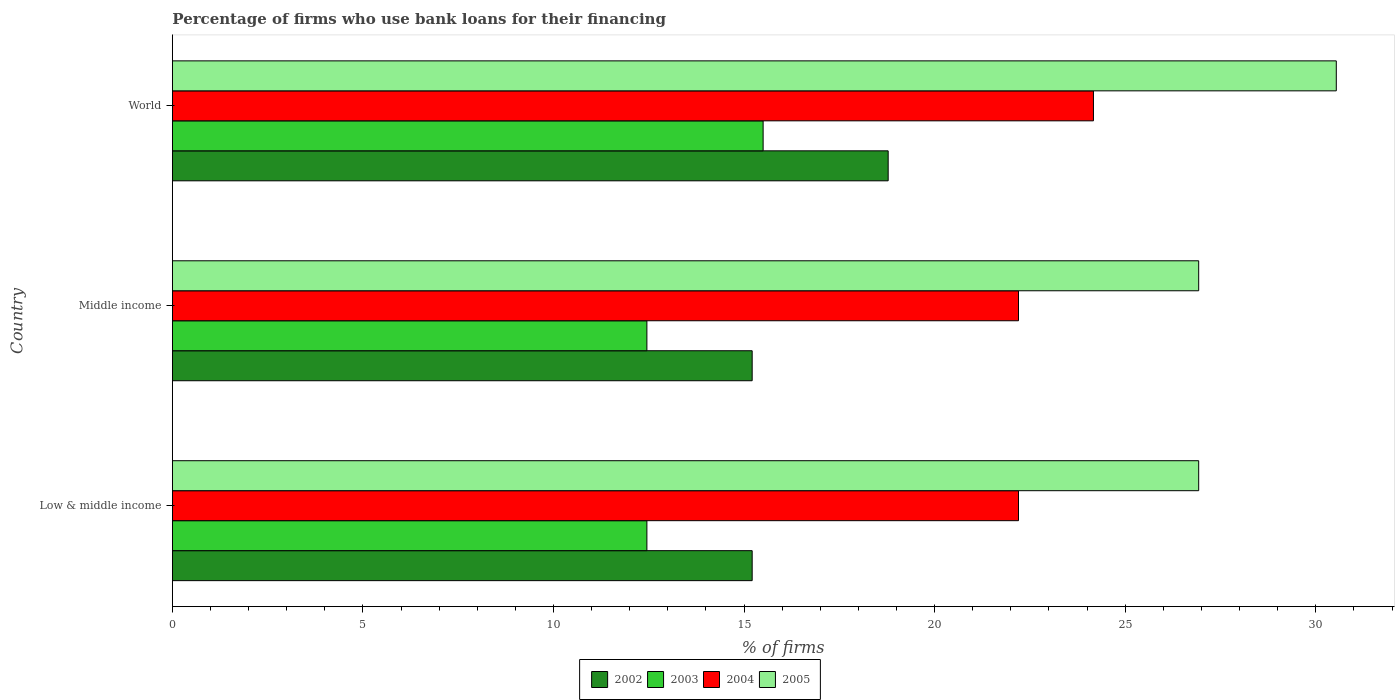How many groups of bars are there?
Ensure brevity in your answer.  3. Are the number of bars per tick equal to the number of legend labels?
Offer a very short reply. Yes. Are the number of bars on each tick of the Y-axis equal?
Your answer should be very brief. Yes. How many bars are there on the 3rd tick from the bottom?
Your answer should be compact. 4. What is the percentage of firms who use bank loans for their financing in 2003 in Low & middle income?
Provide a succinct answer. 12.45. Across all countries, what is the maximum percentage of firms who use bank loans for their financing in 2002?
Your response must be concise. 18.78. Across all countries, what is the minimum percentage of firms who use bank loans for their financing in 2003?
Provide a succinct answer. 12.45. What is the total percentage of firms who use bank loans for their financing in 2003 in the graph?
Keep it short and to the point. 40.4. What is the difference between the percentage of firms who use bank loans for their financing in 2004 in Middle income and that in World?
Offer a terse response. -1.97. What is the difference between the percentage of firms who use bank loans for their financing in 2005 in Middle income and the percentage of firms who use bank loans for their financing in 2002 in World?
Offer a terse response. 8.15. What is the average percentage of firms who use bank loans for their financing in 2005 per country?
Your answer should be very brief. 28.13. What is the difference between the percentage of firms who use bank loans for their financing in 2004 and percentage of firms who use bank loans for their financing in 2005 in Middle income?
Offer a very short reply. -4.73. In how many countries, is the percentage of firms who use bank loans for their financing in 2002 greater than 25 %?
Provide a succinct answer. 0. What is the ratio of the percentage of firms who use bank loans for their financing in 2004 in Low & middle income to that in World?
Ensure brevity in your answer.  0.92. What is the difference between the highest and the second highest percentage of firms who use bank loans for their financing in 2004?
Provide a succinct answer. 1.97. What is the difference between the highest and the lowest percentage of firms who use bank loans for their financing in 2002?
Provide a succinct answer. 3.57. In how many countries, is the percentage of firms who use bank loans for their financing in 2005 greater than the average percentage of firms who use bank loans for their financing in 2005 taken over all countries?
Provide a short and direct response. 1. What does the 2nd bar from the bottom in Low & middle income represents?
Offer a terse response. 2003. Are all the bars in the graph horizontal?
Provide a succinct answer. Yes. How many countries are there in the graph?
Your response must be concise. 3. What is the difference between two consecutive major ticks on the X-axis?
Offer a very short reply. 5. Does the graph contain grids?
Keep it short and to the point. No. How many legend labels are there?
Keep it short and to the point. 4. What is the title of the graph?
Ensure brevity in your answer.  Percentage of firms who use bank loans for their financing. Does "1970" appear as one of the legend labels in the graph?
Ensure brevity in your answer.  No. What is the label or title of the X-axis?
Ensure brevity in your answer.  % of firms. What is the label or title of the Y-axis?
Your answer should be very brief. Country. What is the % of firms of 2002 in Low & middle income?
Offer a terse response. 15.21. What is the % of firms in 2003 in Low & middle income?
Offer a terse response. 12.45. What is the % of firms of 2004 in Low & middle income?
Provide a succinct answer. 22.2. What is the % of firms of 2005 in Low & middle income?
Ensure brevity in your answer.  26.93. What is the % of firms of 2002 in Middle income?
Offer a terse response. 15.21. What is the % of firms of 2003 in Middle income?
Your answer should be very brief. 12.45. What is the % of firms in 2004 in Middle income?
Provide a short and direct response. 22.2. What is the % of firms of 2005 in Middle income?
Make the answer very short. 26.93. What is the % of firms in 2002 in World?
Your response must be concise. 18.78. What is the % of firms of 2003 in World?
Your answer should be very brief. 15.5. What is the % of firms of 2004 in World?
Offer a very short reply. 24.17. What is the % of firms of 2005 in World?
Offer a terse response. 30.54. Across all countries, what is the maximum % of firms of 2002?
Keep it short and to the point. 18.78. Across all countries, what is the maximum % of firms in 2003?
Provide a short and direct response. 15.5. Across all countries, what is the maximum % of firms of 2004?
Provide a succinct answer. 24.17. Across all countries, what is the maximum % of firms of 2005?
Your response must be concise. 30.54. Across all countries, what is the minimum % of firms of 2002?
Your answer should be compact. 15.21. Across all countries, what is the minimum % of firms in 2003?
Keep it short and to the point. 12.45. Across all countries, what is the minimum % of firms in 2004?
Offer a very short reply. 22.2. Across all countries, what is the minimum % of firms in 2005?
Provide a succinct answer. 26.93. What is the total % of firms in 2002 in the graph?
Offer a terse response. 49.21. What is the total % of firms in 2003 in the graph?
Make the answer very short. 40.4. What is the total % of firms of 2004 in the graph?
Make the answer very short. 68.57. What is the total % of firms of 2005 in the graph?
Your answer should be very brief. 84.39. What is the difference between the % of firms of 2002 in Low & middle income and that in Middle income?
Make the answer very short. 0. What is the difference between the % of firms of 2002 in Low & middle income and that in World?
Offer a terse response. -3.57. What is the difference between the % of firms of 2003 in Low & middle income and that in World?
Your response must be concise. -3.05. What is the difference between the % of firms in 2004 in Low & middle income and that in World?
Your answer should be compact. -1.97. What is the difference between the % of firms in 2005 in Low & middle income and that in World?
Give a very brief answer. -3.61. What is the difference between the % of firms of 2002 in Middle income and that in World?
Offer a very short reply. -3.57. What is the difference between the % of firms in 2003 in Middle income and that in World?
Your answer should be very brief. -3.05. What is the difference between the % of firms in 2004 in Middle income and that in World?
Ensure brevity in your answer.  -1.97. What is the difference between the % of firms in 2005 in Middle income and that in World?
Provide a short and direct response. -3.61. What is the difference between the % of firms in 2002 in Low & middle income and the % of firms in 2003 in Middle income?
Your response must be concise. 2.76. What is the difference between the % of firms of 2002 in Low & middle income and the % of firms of 2004 in Middle income?
Provide a short and direct response. -6.99. What is the difference between the % of firms in 2002 in Low & middle income and the % of firms in 2005 in Middle income?
Offer a very short reply. -11.72. What is the difference between the % of firms in 2003 in Low & middle income and the % of firms in 2004 in Middle income?
Give a very brief answer. -9.75. What is the difference between the % of firms in 2003 in Low & middle income and the % of firms in 2005 in Middle income?
Provide a short and direct response. -14.48. What is the difference between the % of firms of 2004 in Low & middle income and the % of firms of 2005 in Middle income?
Keep it short and to the point. -4.73. What is the difference between the % of firms of 2002 in Low & middle income and the % of firms of 2003 in World?
Provide a succinct answer. -0.29. What is the difference between the % of firms of 2002 in Low & middle income and the % of firms of 2004 in World?
Ensure brevity in your answer.  -8.95. What is the difference between the % of firms of 2002 in Low & middle income and the % of firms of 2005 in World?
Keep it short and to the point. -15.33. What is the difference between the % of firms of 2003 in Low & middle income and the % of firms of 2004 in World?
Ensure brevity in your answer.  -11.72. What is the difference between the % of firms of 2003 in Low & middle income and the % of firms of 2005 in World?
Provide a succinct answer. -18.09. What is the difference between the % of firms of 2004 in Low & middle income and the % of firms of 2005 in World?
Your answer should be very brief. -8.34. What is the difference between the % of firms of 2002 in Middle income and the % of firms of 2003 in World?
Provide a succinct answer. -0.29. What is the difference between the % of firms of 2002 in Middle income and the % of firms of 2004 in World?
Your response must be concise. -8.95. What is the difference between the % of firms in 2002 in Middle income and the % of firms in 2005 in World?
Make the answer very short. -15.33. What is the difference between the % of firms of 2003 in Middle income and the % of firms of 2004 in World?
Offer a very short reply. -11.72. What is the difference between the % of firms in 2003 in Middle income and the % of firms in 2005 in World?
Provide a succinct answer. -18.09. What is the difference between the % of firms in 2004 in Middle income and the % of firms in 2005 in World?
Your answer should be very brief. -8.34. What is the average % of firms in 2002 per country?
Make the answer very short. 16.4. What is the average % of firms in 2003 per country?
Provide a short and direct response. 13.47. What is the average % of firms in 2004 per country?
Provide a succinct answer. 22.86. What is the average % of firms in 2005 per country?
Your response must be concise. 28.13. What is the difference between the % of firms in 2002 and % of firms in 2003 in Low & middle income?
Provide a succinct answer. 2.76. What is the difference between the % of firms in 2002 and % of firms in 2004 in Low & middle income?
Your response must be concise. -6.99. What is the difference between the % of firms of 2002 and % of firms of 2005 in Low & middle income?
Your answer should be very brief. -11.72. What is the difference between the % of firms of 2003 and % of firms of 2004 in Low & middle income?
Provide a short and direct response. -9.75. What is the difference between the % of firms in 2003 and % of firms in 2005 in Low & middle income?
Give a very brief answer. -14.48. What is the difference between the % of firms in 2004 and % of firms in 2005 in Low & middle income?
Offer a terse response. -4.73. What is the difference between the % of firms of 2002 and % of firms of 2003 in Middle income?
Ensure brevity in your answer.  2.76. What is the difference between the % of firms of 2002 and % of firms of 2004 in Middle income?
Your answer should be very brief. -6.99. What is the difference between the % of firms in 2002 and % of firms in 2005 in Middle income?
Offer a very short reply. -11.72. What is the difference between the % of firms of 2003 and % of firms of 2004 in Middle income?
Your answer should be very brief. -9.75. What is the difference between the % of firms in 2003 and % of firms in 2005 in Middle income?
Your answer should be very brief. -14.48. What is the difference between the % of firms of 2004 and % of firms of 2005 in Middle income?
Provide a short and direct response. -4.73. What is the difference between the % of firms in 2002 and % of firms in 2003 in World?
Keep it short and to the point. 3.28. What is the difference between the % of firms in 2002 and % of firms in 2004 in World?
Your answer should be compact. -5.39. What is the difference between the % of firms of 2002 and % of firms of 2005 in World?
Keep it short and to the point. -11.76. What is the difference between the % of firms of 2003 and % of firms of 2004 in World?
Make the answer very short. -8.67. What is the difference between the % of firms of 2003 and % of firms of 2005 in World?
Ensure brevity in your answer.  -15.04. What is the difference between the % of firms of 2004 and % of firms of 2005 in World?
Ensure brevity in your answer.  -6.37. What is the ratio of the % of firms in 2002 in Low & middle income to that in Middle income?
Offer a very short reply. 1. What is the ratio of the % of firms of 2005 in Low & middle income to that in Middle income?
Provide a succinct answer. 1. What is the ratio of the % of firms of 2002 in Low & middle income to that in World?
Keep it short and to the point. 0.81. What is the ratio of the % of firms in 2003 in Low & middle income to that in World?
Your response must be concise. 0.8. What is the ratio of the % of firms in 2004 in Low & middle income to that in World?
Ensure brevity in your answer.  0.92. What is the ratio of the % of firms in 2005 in Low & middle income to that in World?
Your answer should be compact. 0.88. What is the ratio of the % of firms in 2002 in Middle income to that in World?
Ensure brevity in your answer.  0.81. What is the ratio of the % of firms in 2003 in Middle income to that in World?
Give a very brief answer. 0.8. What is the ratio of the % of firms in 2004 in Middle income to that in World?
Provide a succinct answer. 0.92. What is the ratio of the % of firms in 2005 in Middle income to that in World?
Keep it short and to the point. 0.88. What is the difference between the highest and the second highest % of firms in 2002?
Offer a very short reply. 3.57. What is the difference between the highest and the second highest % of firms in 2003?
Your answer should be compact. 3.05. What is the difference between the highest and the second highest % of firms in 2004?
Provide a succinct answer. 1.97. What is the difference between the highest and the second highest % of firms of 2005?
Give a very brief answer. 3.61. What is the difference between the highest and the lowest % of firms of 2002?
Your answer should be very brief. 3.57. What is the difference between the highest and the lowest % of firms in 2003?
Your answer should be very brief. 3.05. What is the difference between the highest and the lowest % of firms in 2004?
Ensure brevity in your answer.  1.97. What is the difference between the highest and the lowest % of firms in 2005?
Your response must be concise. 3.61. 